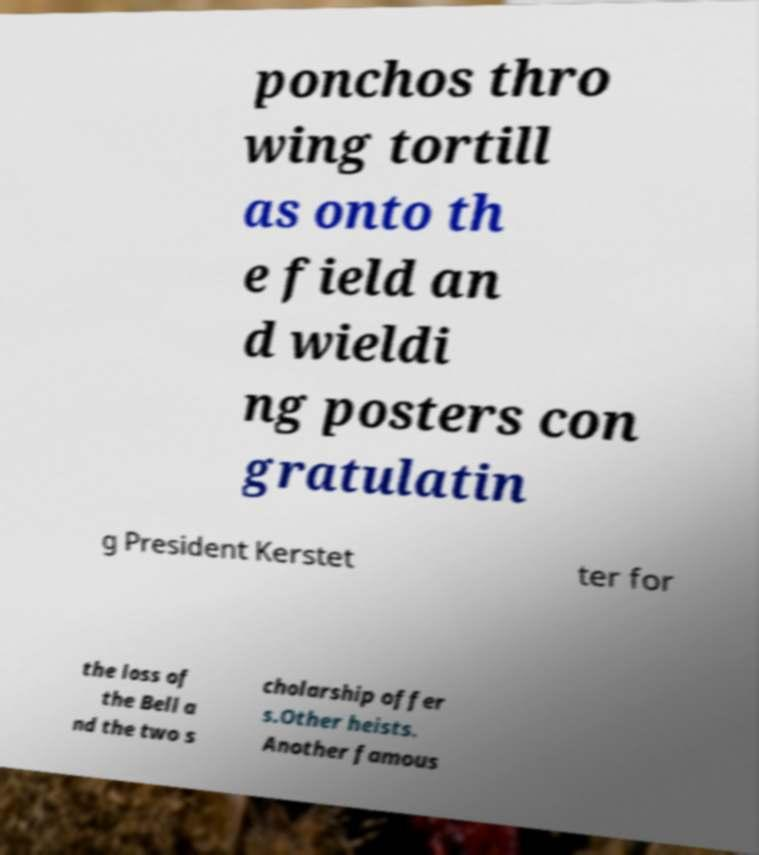What messages or text are displayed in this image? I need them in a readable, typed format. ponchos thro wing tortill as onto th e field an d wieldi ng posters con gratulatin g President Kerstet ter for the loss of the Bell a nd the two s cholarship offer s.Other heists. Another famous 